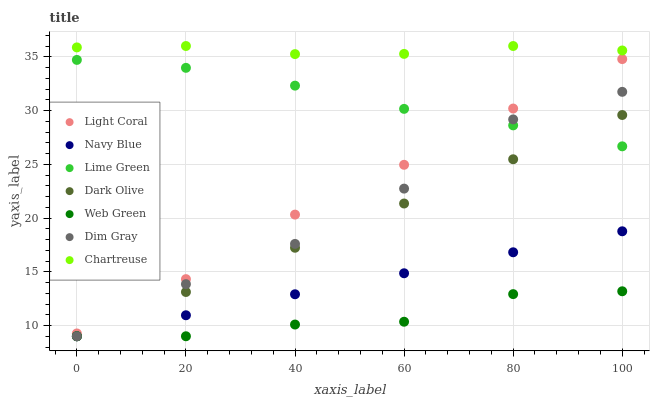Does Web Green have the minimum area under the curve?
Answer yes or no. Yes. Does Chartreuse have the maximum area under the curve?
Answer yes or no. Yes. Does Navy Blue have the minimum area under the curve?
Answer yes or no. No. Does Navy Blue have the maximum area under the curve?
Answer yes or no. No. Is Navy Blue the smoothest?
Answer yes or no. Yes. Is Dim Gray the roughest?
Answer yes or no. Yes. Is Dark Olive the smoothest?
Answer yes or no. No. Is Dark Olive the roughest?
Answer yes or no. No. Does Dim Gray have the lowest value?
Answer yes or no. Yes. Does Light Coral have the lowest value?
Answer yes or no. No. Does Chartreuse have the highest value?
Answer yes or no. Yes. Does Navy Blue have the highest value?
Answer yes or no. No. Is Web Green less than Chartreuse?
Answer yes or no. Yes. Is Lime Green greater than Web Green?
Answer yes or no. Yes. Does Navy Blue intersect Dark Olive?
Answer yes or no. Yes. Is Navy Blue less than Dark Olive?
Answer yes or no. No. Is Navy Blue greater than Dark Olive?
Answer yes or no. No. Does Web Green intersect Chartreuse?
Answer yes or no. No. 